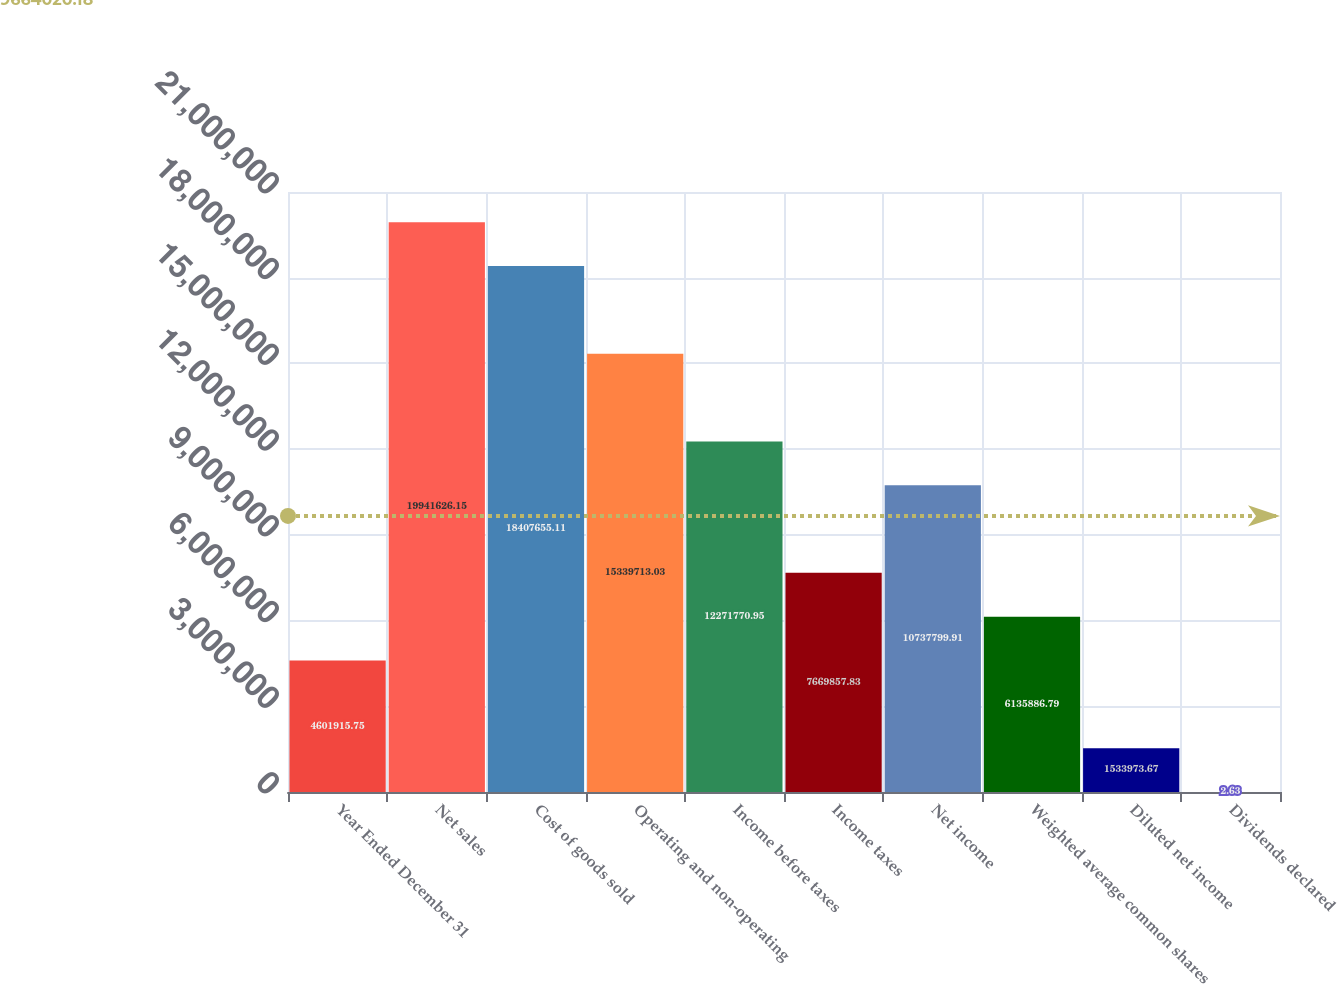<chart> <loc_0><loc_0><loc_500><loc_500><bar_chart><fcel>Year Ended December 31<fcel>Net sales<fcel>Cost of goods sold<fcel>Operating and non-operating<fcel>Income before taxes<fcel>Income taxes<fcel>Net income<fcel>Weighted average common shares<fcel>Diluted net income<fcel>Dividends declared<nl><fcel>4.60192e+06<fcel>1.99416e+07<fcel>1.84077e+07<fcel>1.53397e+07<fcel>1.22718e+07<fcel>7.66986e+06<fcel>1.07378e+07<fcel>6.13589e+06<fcel>1.53397e+06<fcel>2.63<nl></chart> 